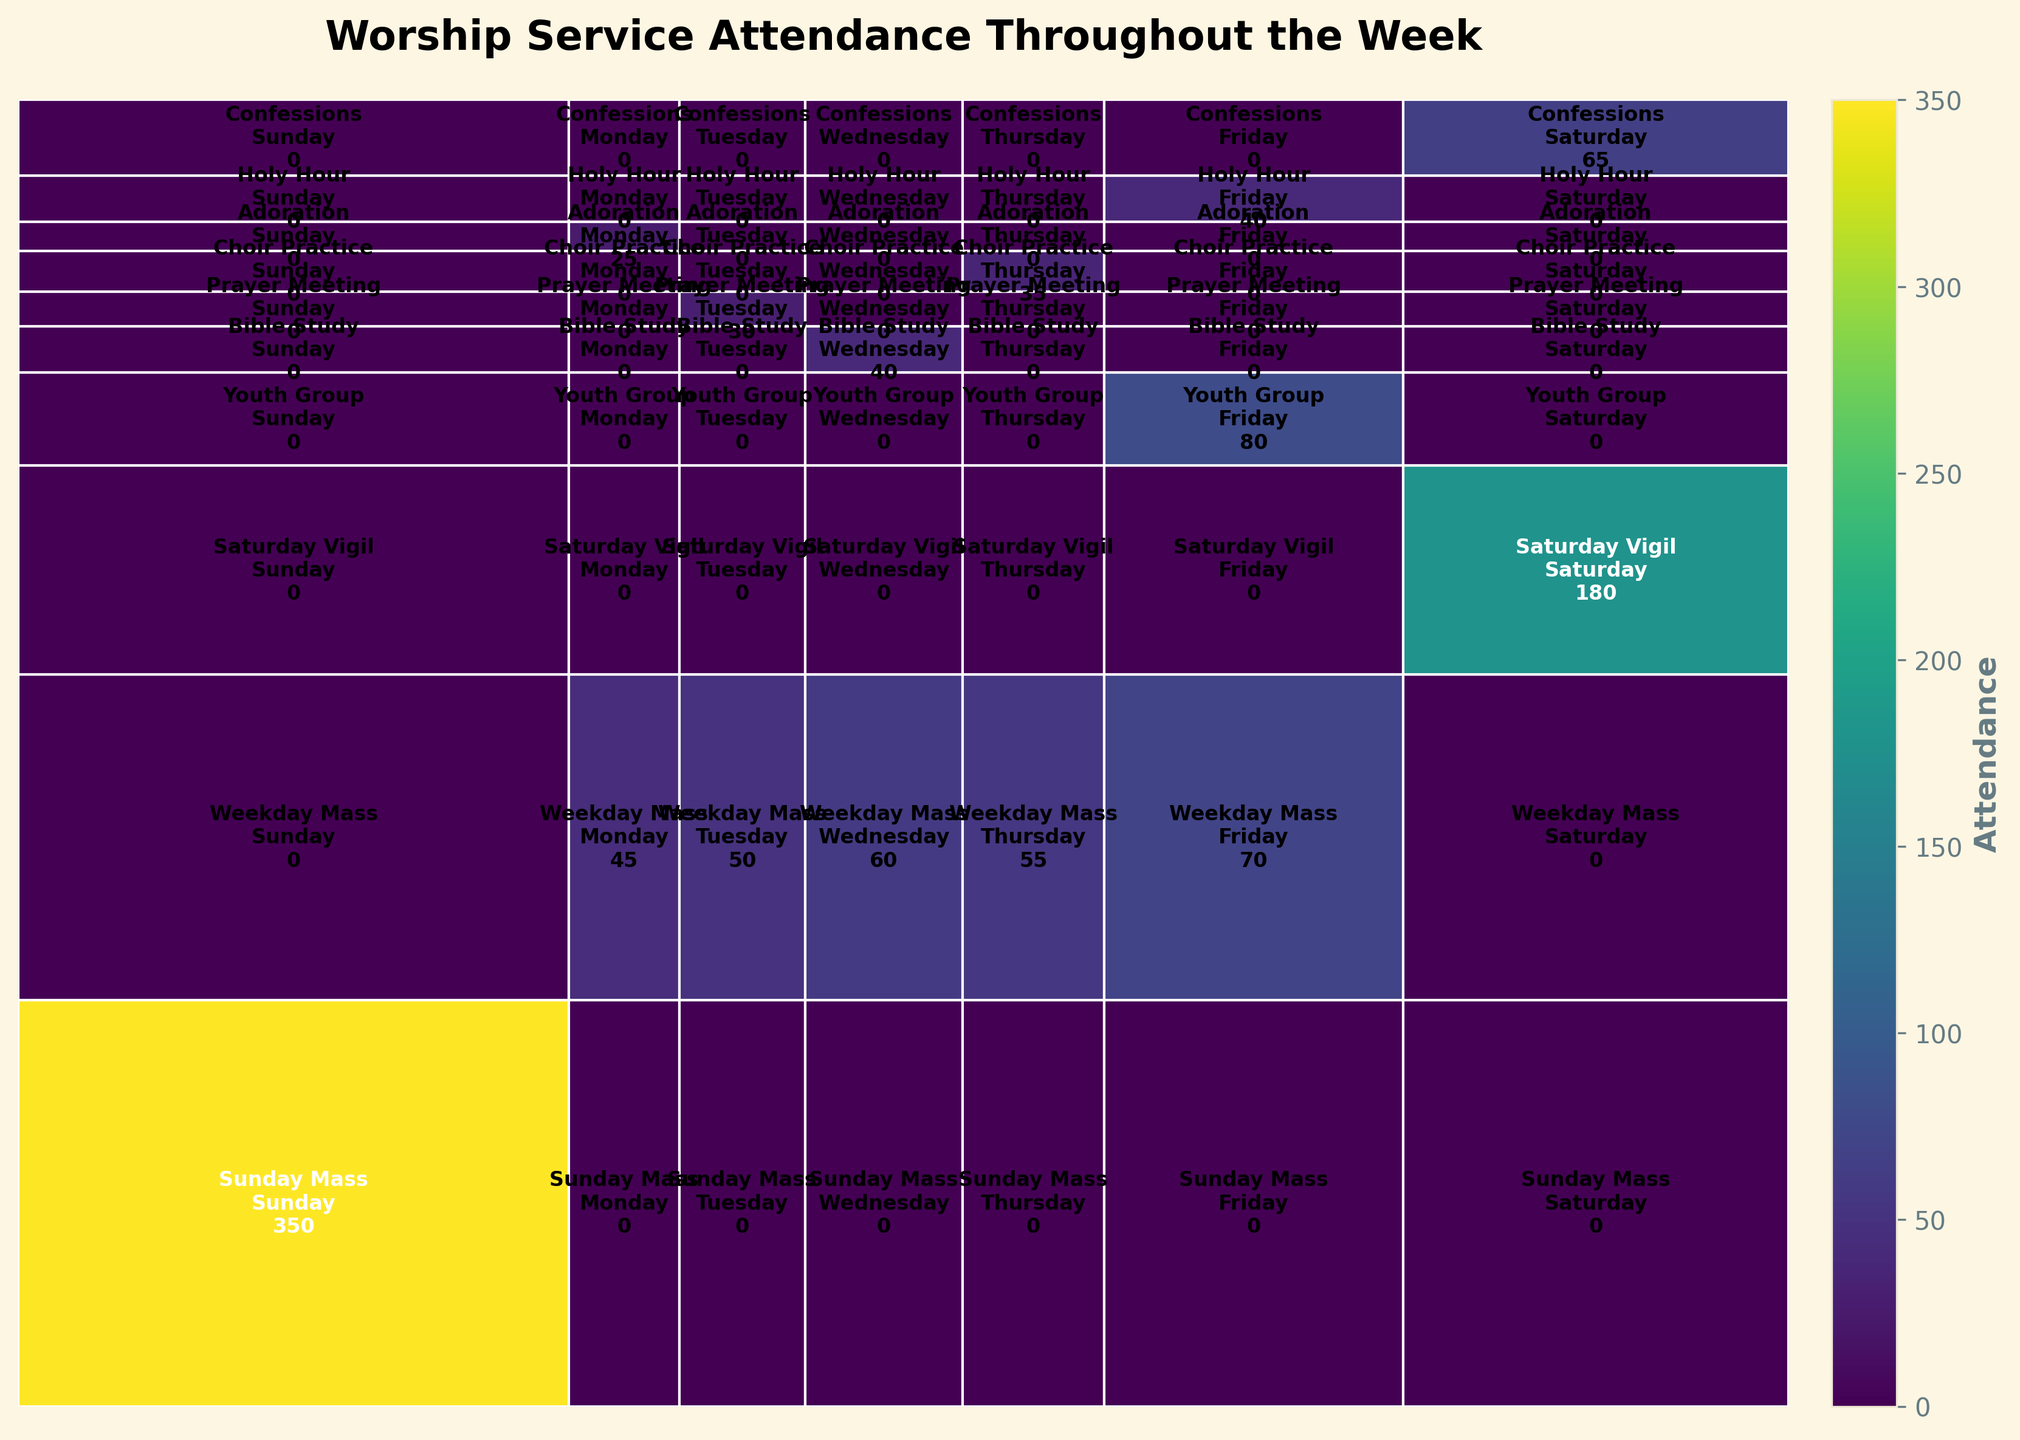What's the title of the plot? The title of the plot is usually located at the top and provides a brief description. In this case, it reads "Worship Service Attendance Throughout the Week".
Answer: Worship Service Attendance Throughout the Week Which day of the week has the highest total attendance? Look at the column widths representing each day of the week. The widest column indicates the day with the highest attendance. The plot shows Sunday with the widest column, reflecting the highest total attendance.
Answer: Sunday What is the attendance for Sunday Mass? Locate the rectangle representing Sunday Mass on Sunday. The text inside the rectangle provides the attendance number. The rectangle for Sunday Mass on Sunday shows 350.
Answer: 350 Compare the attendance of Weekday Mass on Wednesday and Friday. Which is higher? Look at the rectangles for "Weekday Mass" on Wednesday and Friday. The text inside these rectangles shows the attendance numbers. Wednesday has 60, and Friday has 70.
Answer: Friday What service type has the lowest attendance on any given day? Identify the smallest rectangles in the plot, representing the lowest attendance. Adoration on Monday and Prayer Meeting on Tuesday both have small attendance figures, but Adoration on Monday with 25 is the lowest.
Answer: Adoration on Monday How does the attendance for Saturday Vigil compare to the combined attendance for all weekday masses on Monday? Check the attendance for Saturday Vigil first (180). Then, sum up the attendance for all weekday masses on Monday (45). Compare these two values to find which is greater.
Answer: Saturday Vigil Which service has a consistent attendance (similar numbers) throughout the week? Compare the attendance numbers of each service type across different days. Weekday Masses from Monday to Friday have relatively similar numbers (45, 50, 60, 55, 70).
Answer: Weekday Mass What are the two service types with activities on Wednesday? Scan the rows corresponding to Wednesday. The two identified rectangles represent "Weekday Mass" and "Bible Study".
Answer: Weekday Mass and Bible Study What's the proportion of Friday's total attendance to the overall week's attendance? Sum up the attendance numbers displayed on Friday, then divide by the total attendance of the week. Attendance on Friday is 70 (Weekday Mass) + 80 (Youth Group) + 40 (Holy Hour) = 190. The overall week's total attendance is 1080. Calculate 190/1080.
Answer: ~17.6% How does the attendance for Sunday Mass compare to the average attendance for all other services throughout the week? Find the sum of all attendances excluding Sunday Mass and then calculate the average. Sum = 1080 - 350, Average = 730 / 13 = ~56.15. Compare 350 to 56.15.
Answer: Much higher 